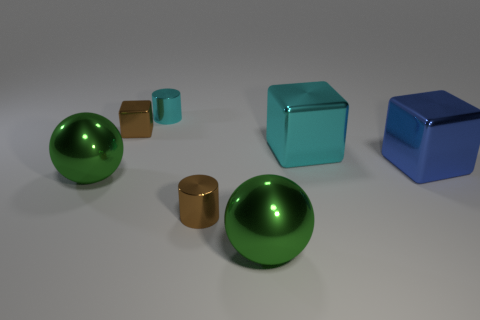Do the shiny cylinder in front of the large cyan block and the tiny shiny block that is left of the blue cube have the same color?
Offer a very short reply. Yes. What number of other things are there of the same material as the small block
Offer a very short reply. 6. Are there any red metal blocks?
Give a very brief answer. No. Is the green sphere on the left side of the brown metal cylinder made of the same material as the tiny block?
Offer a very short reply. Yes. There is a tiny thing that is the same color as the small shiny cube; what material is it?
Make the answer very short. Metal. Is the number of large blue metal blocks less than the number of cyan rubber cylinders?
Your answer should be very brief. No. There is a small cylinder behind the brown metal cube; is its color the same as the small metallic cube?
Your response must be concise. No. The small cube that is made of the same material as the brown cylinder is what color?
Provide a short and direct response. Brown. Do the blue cube and the cyan block have the same size?
Provide a succinct answer. Yes. What material is the blue block?
Provide a succinct answer. Metal. 